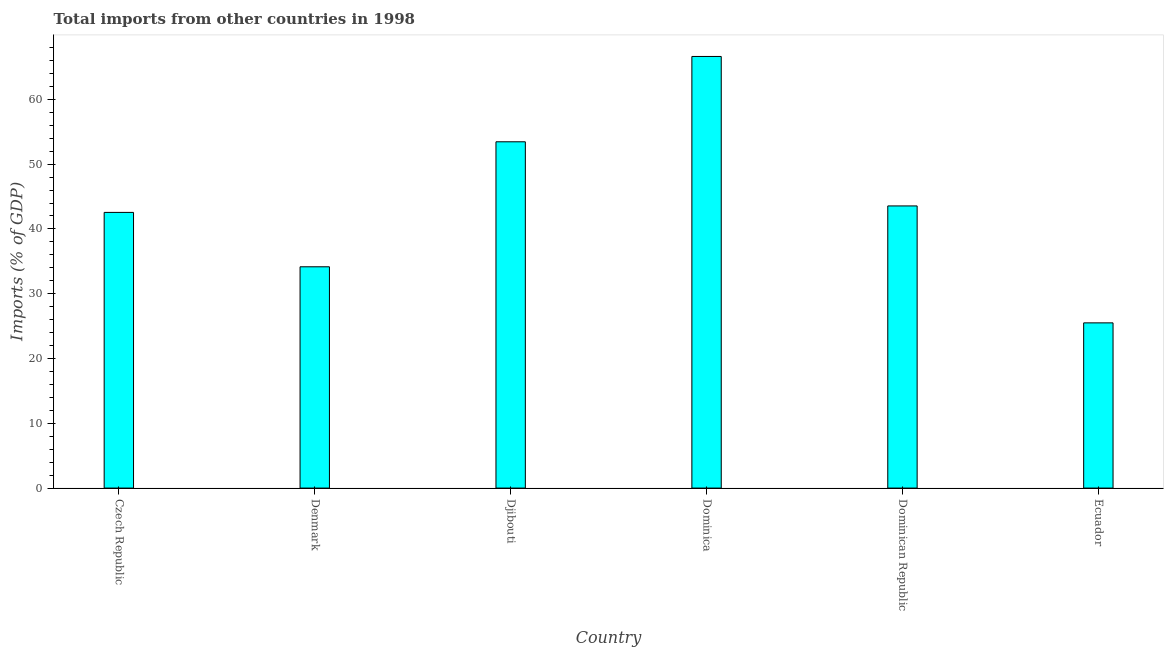Does the graph contain any zero values?
Ensure brevity in your answer.  No. Does the graph contain grids?
Provide a succinct answer. No. What is the title of the graph?
Your response must be concise. Total imports from other countries in 1998. What is the label or title of the Y-axis?
Make the answer very short. Imports (% of GDP). What is the total imports in Denmark?
Make the answer very short. 34.16. Across all countries, what is the maximum total imports?
Your answer should be compact. 66.62. Across all countries, what is the minimum total imports?
Your answer should be compact. 25.5. In which country was the total imports maximum?
Your response must be concise. Dominica. In which country was the total imports minimum?
Keep it short and to the point. Ecuador. What is the sum of the total imports?
Ensure brevity in your answer.  265.85. What is the difference between the total imports in Denmark and Dominican Republic?
Ensure brevity in your answer.  -9.39. What is the average total imports per country?
Your response must be concise. 44.31. What is the median total imports?
Offer a terse response. 43.05. In how many countries, is the total imports greater than 48 %?
Make the answer very short. 2. What is the ratio of the total imports in Czech Republic to that in Djibouti?
Your answer should be very brief. 0.8. What is the difference between the highest and the second highest total imports?
Keep it short and to the point. 13.17. What is the difference between the highest and the lowest total imports?
Your answer should be very brief. 41.12. In how many countries, is the total imports greater than the average total imports taken over all countries?
Make the answer very short. 2. How many bars are there?
Keep it short and to the point. 6. What is the Imports (% of GDP) of Czech Republic?
Offer a very short reply. 42.56. What is the Imports (% of GDP) in Denmark?
Give a very brief answer. 34.16. What is the Imports (% of GDP) in Djibouti?
Ensure brevity in your answer.  53.45. What is the Imports (% of GDP) of Dominica?
Ensure brevity in your answer.  66.62. What is the Imports (% of GDP) of Dominican Republic?
Keep it short and to the point. 43.55. What is the Imports (% of GDP) of Ecuador?
Provide a succinct answer. 25.5. What is the difference between the Imports (% of GDP) in Czech Republic and Denmark?
Ensure brevity in your answer.  8.4. What is the difference between the Imports (% of GDP) in Czech Republic and Djibouti?
Offer a terse response. -10.9. What is the difference between the Imports (% of GDP) in Czech Republic and Dominica?
Offer a terse response. -24.07. What is the difference between the Imports (% of GDP) in Czech Republic and Dominican Republic?
Your response must be concise. -1. What is the difference between the Imports (% of GDP) in Czech Republic and Ecuador?
Ensure brevity in your answer.  17.05. What is the difference between the Imports (% of GDP) in Denmark and Djibouti?
Ensure brevity in your answer.  -19.29. What is the difference between the Imports (% of GDP) in Denmark and Dominica?
Offer a very short reply. -32.46. What is the difference between the Imports (% of GDP) in Denmark and Dominican Republic?
Make the answer very short. -9.39. What is the difference between the Imports (% of GDP) in Denmark and Ecuador?
Ensure brevity in your answer.  8.66. What is the difference between the Imports (% of GDP) in Djibouti and Dominica?
Give a very brief answer. -13.17. What is the difference between the Imports (% of GDP) in Djibouti and Dominican Republic?
Provide a succinct answer. 9.9. What is the difference between the Imports (% of GDP) in Djibouti and Ecuador?
Your answer should be compact. 27.95. What is the difference between the Imports (% of GDP) in Dominica and Dominican Republic?
Give a very brief answer. 23.07. What is the difference between the Imports (% of GDP) in Dominica and Ecuador?
Provide a short and direct response. 41.12. What is the difference between the Imports (% of GDP) in Dominican Republic and Ecuador?
Provide a short and direct response. 18.05. What is the ratio of the Imports (% of GDP) in Czech Republic to that in Denmark?
Provide a short and direct response. 1.25. What is the ratio of the Imports (% of GDP) in Czech Republic to that in Djibouti?
Your answer should be compact. 0.8. What is the ratio of the Imports (% of GDP) in Czech Republic to that in Dominica?
Ensure brevity in your answer.  0.64. What is the ratio of the Imports (% of GDP) in Czech Republic to that in Dominican Republic?
Your answer should be very brief. 0.98. What is the ratio of the Imports (% of GDP) in Czech Republic to that in Ecuador?
Your answer should be compact. 1.67. What is the ratio of the Imports (% of GDP) in Denmark to that in Djibouti?
Give a very brief answer. 0.64. What is the ratio of the Imports (% of GDP) in Denmark to that in Dominica?
Offer a very short reply. 0.51. What is the ratio of the Imports (% of GDP) in Denmark to that in Dominican Republic?
Provide a succinct answer. 0.78. What is the ratio of the Imports (% of GDP) in Denmark to that in Ecuador?
Provide a short and direct response. 1.34. What is the ratio of the Imports (% of GDP) in Djibouti to that in Dominica?
Make the answer very short. 0.8. What is the ratio of the Imports (% of GDP) in Djibouti to that in Dominican Republic?
Ensure brevity in your answer.  1.23. What is the ratio of the Imports (% of GDP) in Djibouti to that in Ecuador?
Make the answer very short. 2.1. What is the ratio of the Imports (% of GDP) in Dominica to that in Dominican Republic?
Provide a short and direct response. 1.53. What is the ratio of the Imports (% of GDP) in Dominica to that in Ecuador?
Make the answer very short. 2.61. What is the ratio of the Imports (% of GDP) in Dominican Republic to that in Ecuador?
Your answer should be compact. 1.71. 